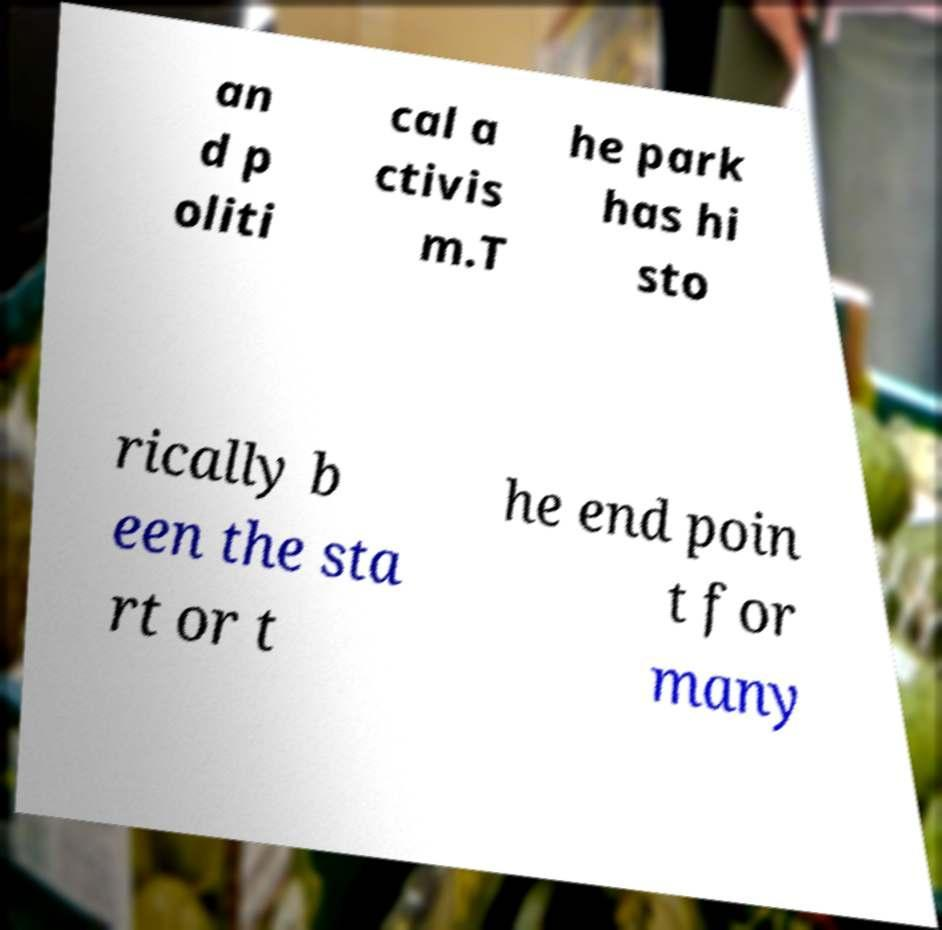For documentation purposes, I need the text within this image transcribed. Could you provide that? an d p oliti cal a ctivis m.T he park has hi sto rically b een the sta rt or t he end poin t for many 